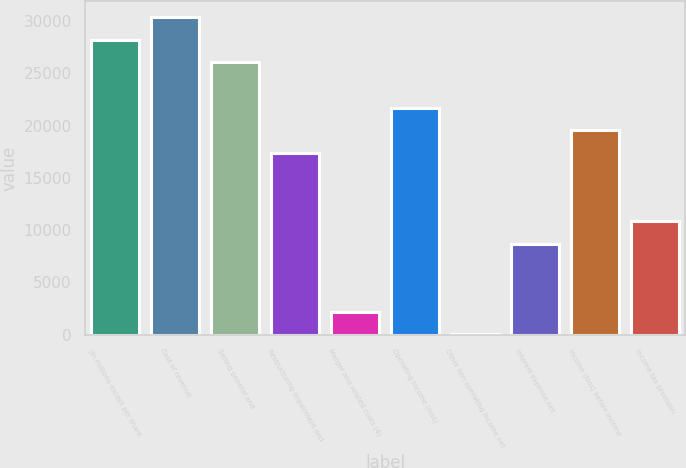<chart> <loc_0><loc_0><loc_500><loc_500><bar_chart><fcel>(In millions except per share<fcel>Cost of revenue<fcel>Selling general and<fcel>Restructuring impairment and<fcel>Merger and related costs (4)<fcel>Operating income (loss)<fcel>Other non operating income net<fcel>Interest expense net<fcel>Income (loss) before income<fcel>Income tax provision<nl><fcel>28229.2<fcel>30398.6<fcel>26059.8<fcel>17382.2<fcel>2196.4<fcel>21721<fcel>27<fcel>8704.6<fcel>19551.6<fcel>10874<nl></chart> 